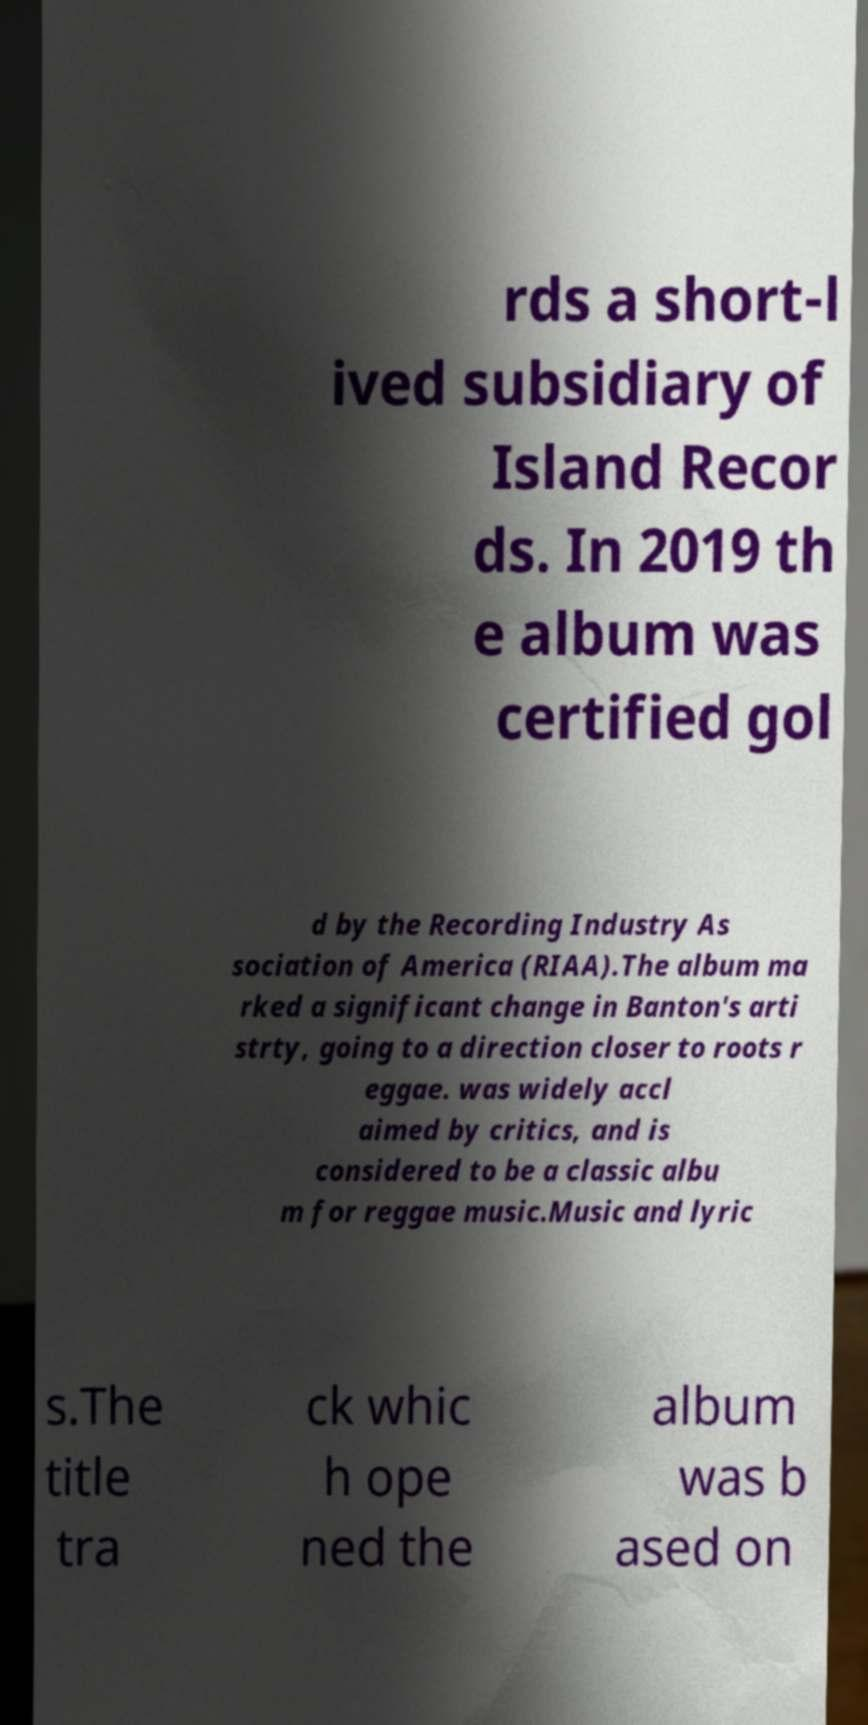Can you accurately transcribe the text from the provided image for me? rds a short-l ived subsidiary of Island Recor ds. In 2019 th e album was certified gol d by the Recording Industry As sociation of America (RIAA).The album ma rked a significant change in Banton's arti strty, going to a direction closer to roots r eggae. was widely accl aimed by critics, and is considered to be a classic albu m for reggae music.Music and lyric s.The title tra ck whic h ope ned the album was b ased on 